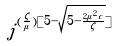<formula> <loc_0><loc_0><loc_500><loc_500>j ^ { ( \frac { \zeta } { \mu } ) [ 5 - \sqrt { 5 - \frac { 2 \mu ^ { 2 } c } { \zeta } } ] }</formula> 